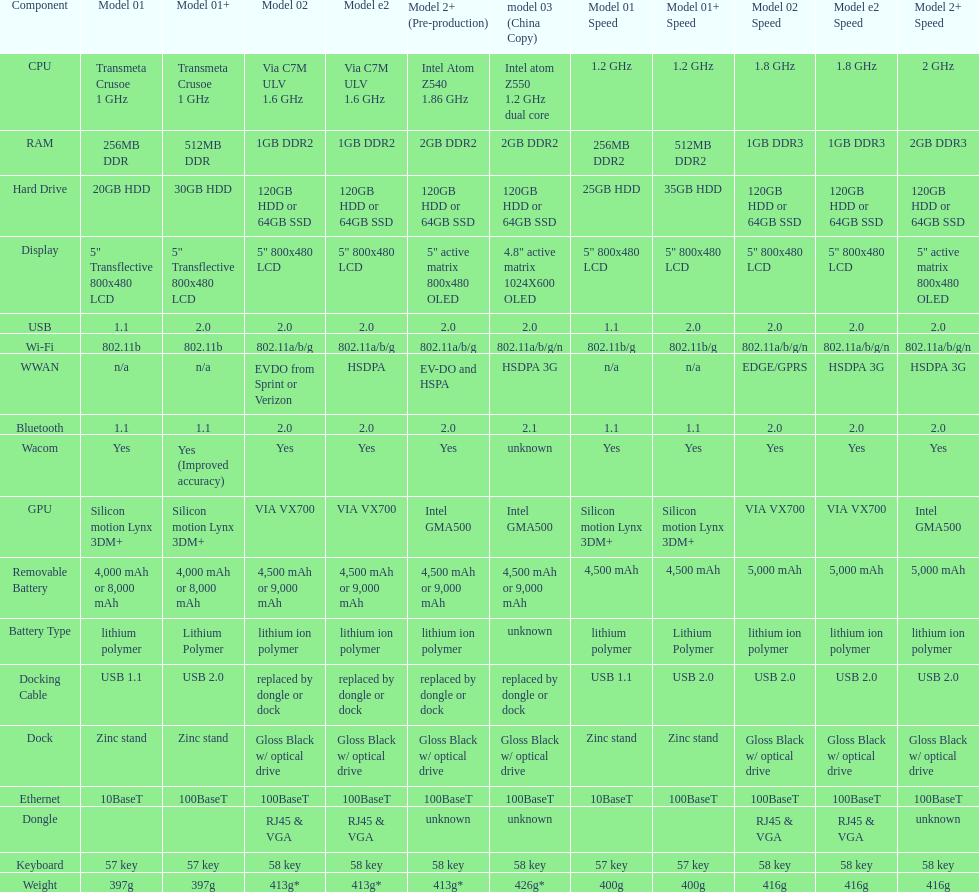Which model weighs the most, according to the table? Model 03 (china copy). 